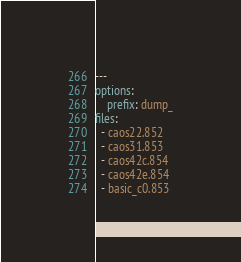Convert code to text. <code><loc_0><loc_0><loc_500><loc_500><_YAML_>---
options:
    prefix: dump_
files:
  - caos22.852
  - caos31.853
  - caos42c.854
  - caos42e.854
  - basic_c0.853

</code> 